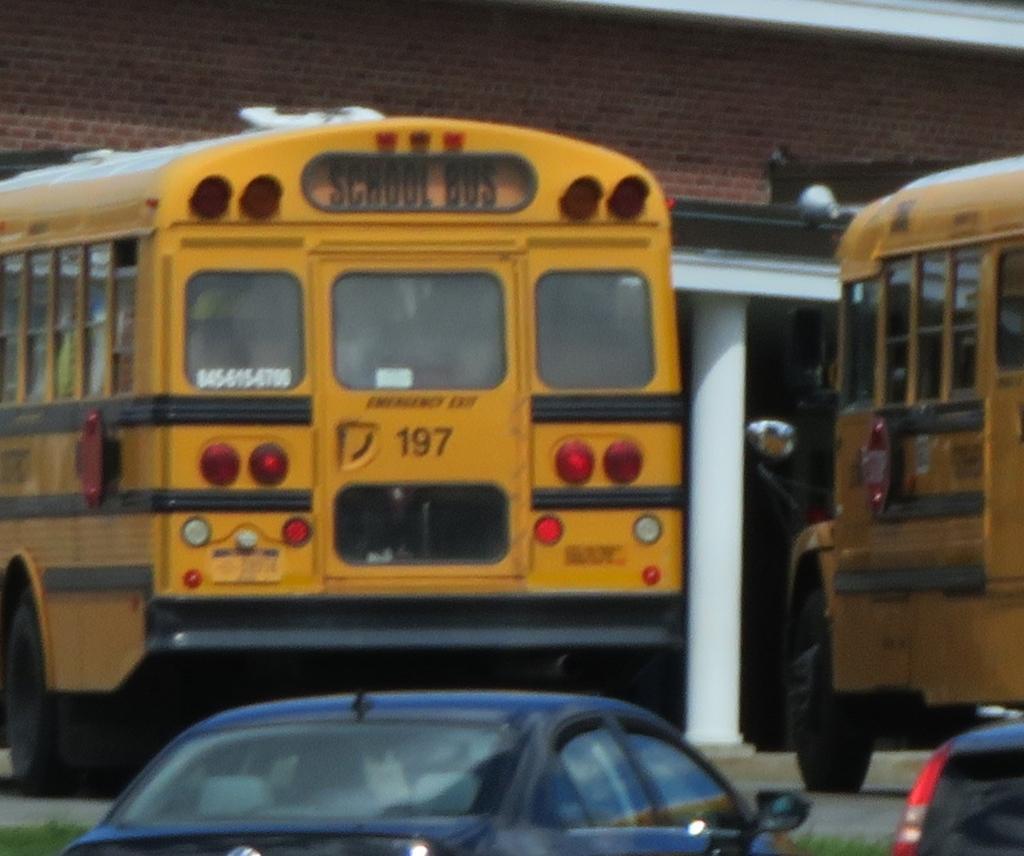Describe this image in one or two sentences. In this image there are two buses , two vehicles, grass and a building. 